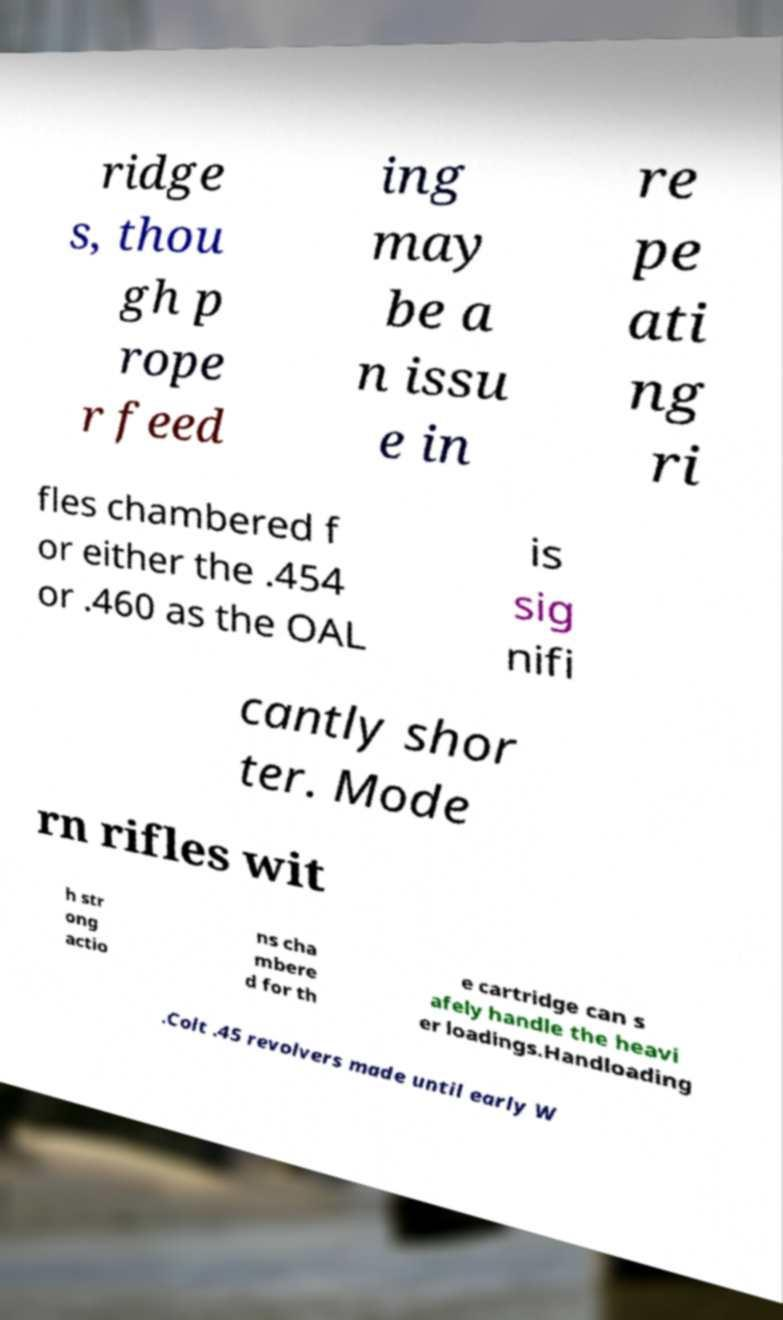I need the written content from this picture converted into text. Can you do that? ridge s, thou gh p rope r feed ing may be a n issu e in re pe ati ng ri fles chambered f or either the .454 or .460 as the OAL is sig nifi cantly shor ter. Mode rn rifles wit h str ong actio ns cha mbere d for th e cartridge can s afely handle the heavi er loadings.Handloading .Colt .45 revolvers made until early W 